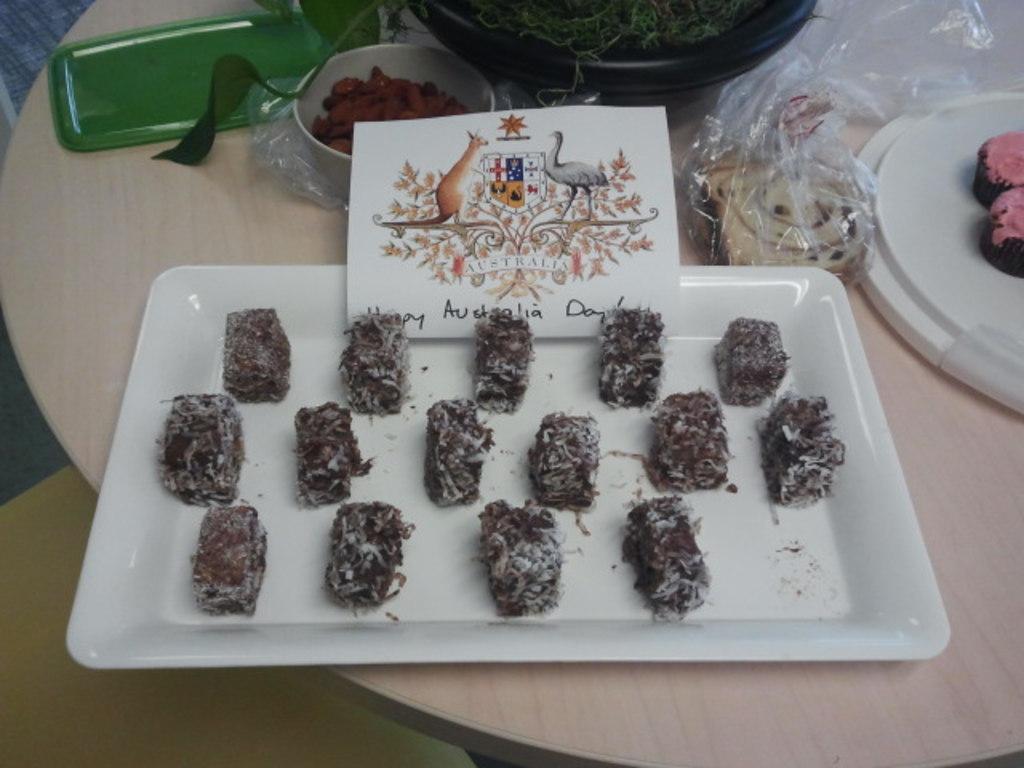Describe this image in one or two sentences. On this wooden table there is a plate, bowl, card, plastic cover, food and objects. 